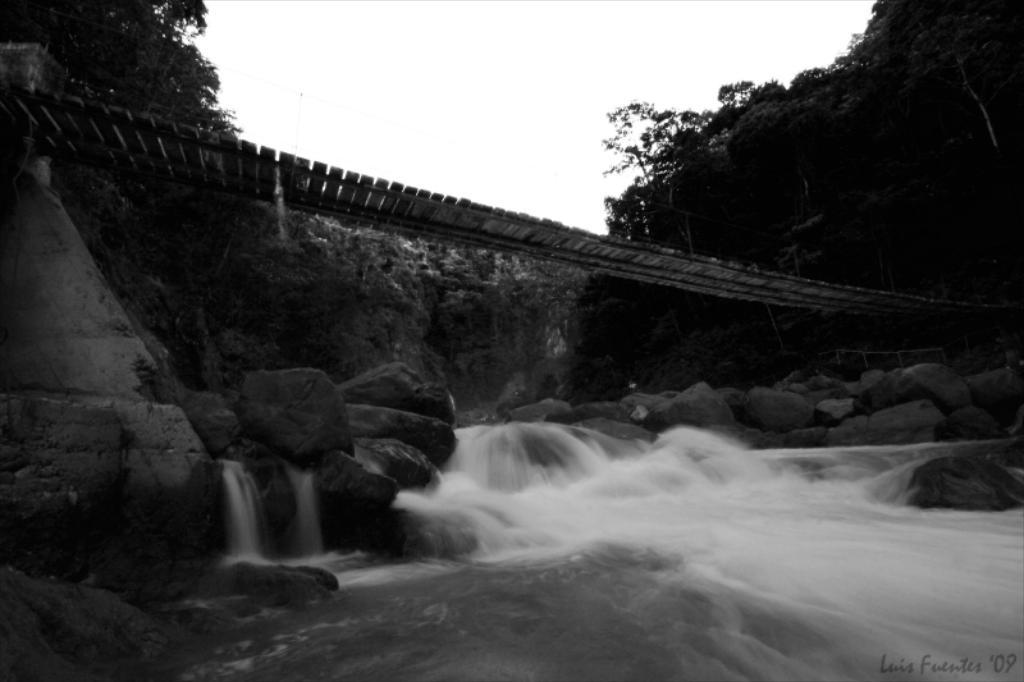What is the main structure in the center of the image? There is a wooden bridge in the center of the image. What can be seen in the background of the image? There is a sky visible in the background of the image, along with trees. What is present at the bottom of the image? Rocks and water are visible at the bottom of the image. What type of juice is being served to the boys in the image? There are no boys or juice present in the image; it features a wooden bridge, sky, trees, rocks, and water. 